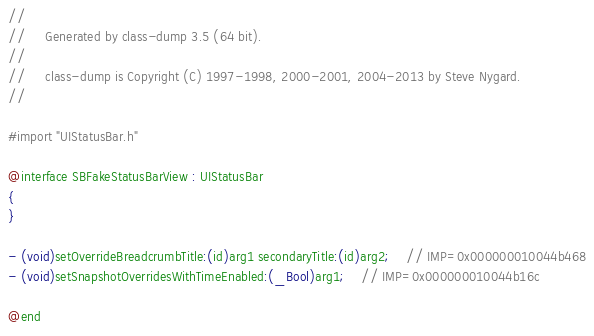<code> <loc_0><loc_0><loc_500><loc_500><_C_>//
//     Generated by class-dump 3.5 (64 bit).
//
//     class-dump is Copyright (C) 1997-1998, 2000-2001, 2004-2013 by Steve Nygard.
//

#import "UIStatusBar.h"

@interface SBFakeStatusBarView : UIStatusBar
{
}

- (void)setOverrideBreadcrumbTitle:(id)arg1 secondaryTitle:(id)arg2;	// IMP=0x000000010044b468
- (void)setSnapshotOverridesWithTimeEnabled:(_Bool)arg1;	// IMP=0x000000010044b16c

@end

</code> 